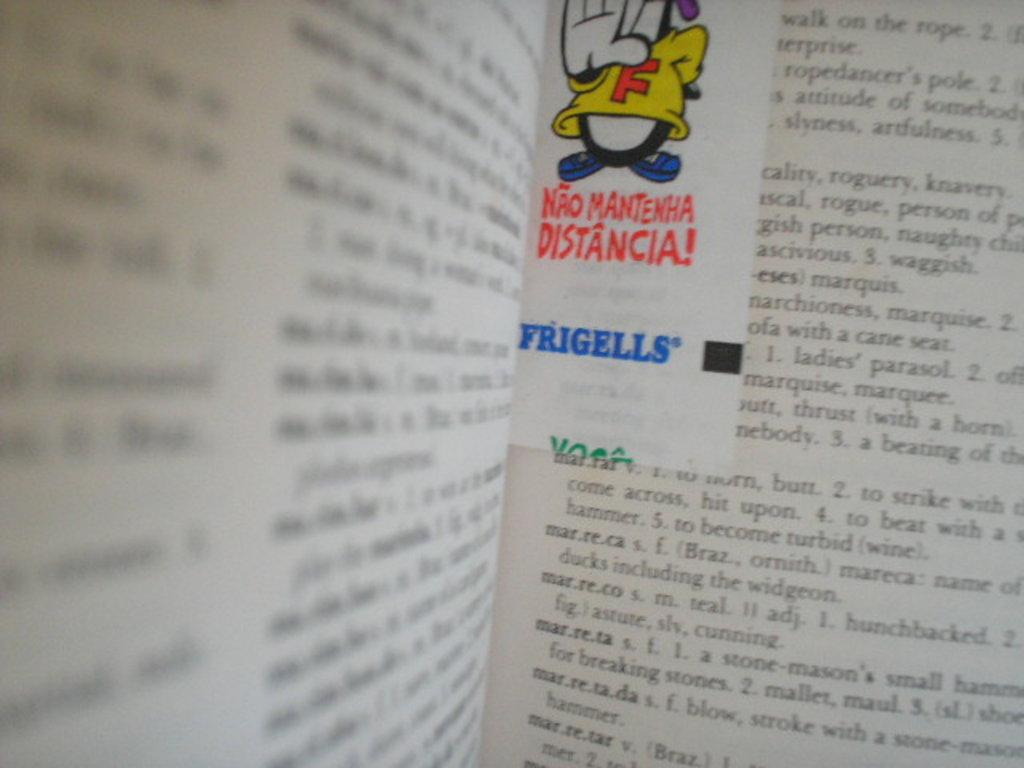What is the company featured on the bookmark?
Your response must be concise. Frigells. What letter is on the cartoon character's shirt?
Provide a succinct answer. F. 